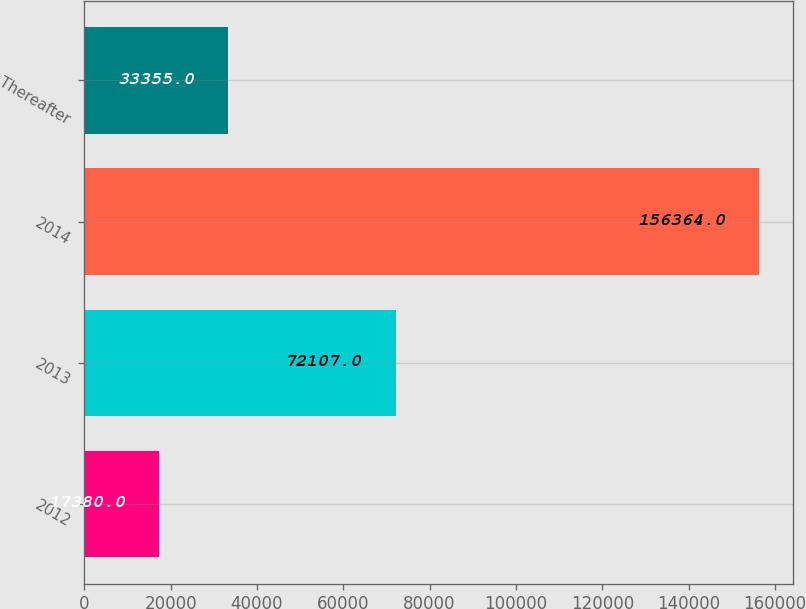Convert chart to OTSL. <chart><loc_0><loc_0><loc_500><loc_500><bar_chart><fcel>2012<fcel>2013<fcel>2014<fcel>Thereafter<nl><fcel>17380<fcel>72107<fcel>156364<fcel>33355<nl></chart> 